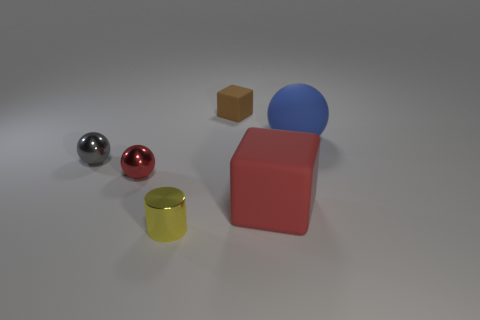Add 2 red matte objects. How many objects exist? 8 Add 4 small cylinders. How many small cylinders are left? 5 Add 1 small gray things. How many small gray things exist? 2 Subtract all blue spheres. How many spheres are left? 2 Subtract all big matte balls. How many balls are left? 2 Subtract 0 purple cubes. How many objects are left? 6 Subtract all cylinders. How many objects are left? 5 Subtract 2 balls. How many balls are left? 1 Subtract all yellow balls. Subtract all brown cubes. How many balls are left? 3 Subtract all gray spheres. How many red blocks are left? 1 